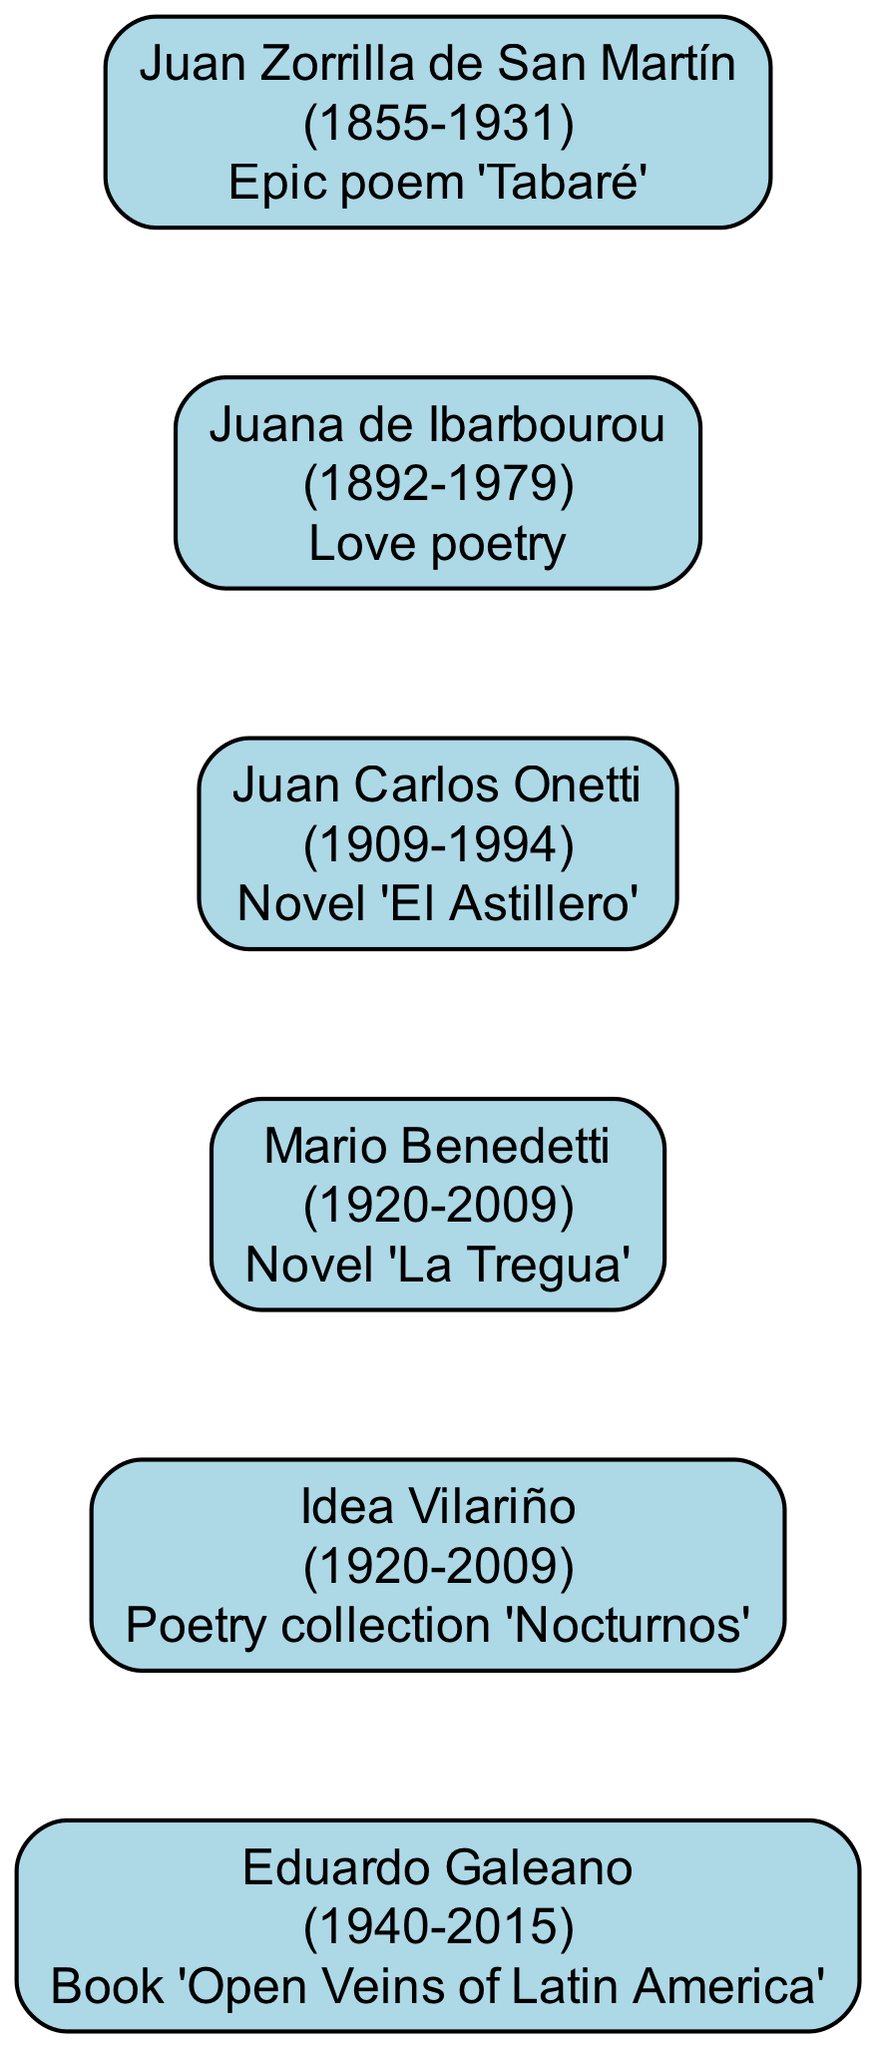What is the birth year of Juan Zorrilla de San Martín? The diagram indicates that Juan Zorrilla de San Martín was born in 1855. This information is found in the label of his node.
Answer: 1855 What literary work is associated with Mario Benedetti? The diagram shows that Mario Benedetti is associated with the novel 'La Tregua', which is mentioned in the label of his node.
Answer: 'La Tregua' Who was born first, Juana de Ibarbourou or Juan Carlos Onetti? By examining the birth years provided in the nodes, Juana de Ibarbourou was born in 1892, and Juan Carlos Onetti was born in 1909. Since 1892 is before 1909, Juana de Ibarbourou was born first.
Answer: Juana de Ibarbourou Which writer contributed love poetry? The diagram shows that Juana de Ibarbourou is noted for her contribution of love poetry, as indicated in the description within her node.
Answer: Juana de Ibarbourou How many writers are featured in the family tree? By counting the individual nodes displayed in the diagram, there are a total of six notable writers represented. This includes Juan Zorrilla de San Martín, Juana de Ibarbourou, Mario Benedetti, Juan Carlos Onetti, Idea Vilariño, and Eduardo Galeano.
Answer: 6 What is the contribution of Eduardo Galeano? The contribution of Eduardo Galeano, as shown in the diagram, is the book 'Open Veins of Latin America', which is specified in his node's label.
Answer: 'Open Veins of Latin America' Which two writers lived in the same year period? Idea Vilariño and Mario Benedetti both lived from 1920 to 2009, as indicated in their respective nodes, showing they were contemporaries.
Answer: Idea Vilariño and Mario Benedetti What is the significance of the invisible edges in the diagram? The invisible edges in the diagram serve to connect writers based on their birth years, helping to determine the order of their birth and lineage without visually displaying the connections.
Answer: Establish birth order Which writer's work is recognized as an epic poem? The diagram attributes the epic poem 'Tabaré' to Juan Zorrilla de San Martín, according to the information within his node.
Answer: Juan Zorrilla de San Martín 